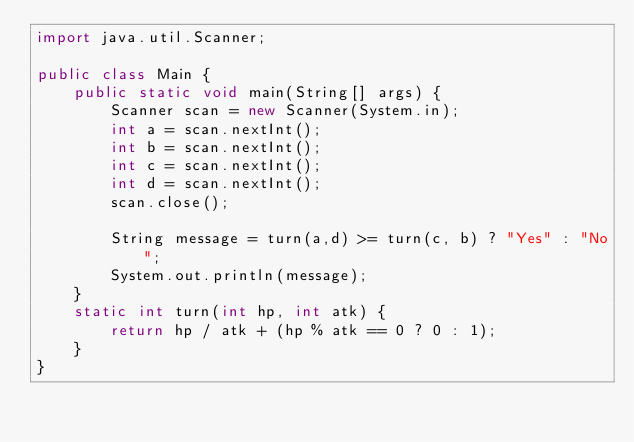Convert code to text. <code><loc_0><loc_0><loc_500><loc_500><_Java_>import java.util.Scanner;

public class Main {
    public static void main(String[] args) {
        Scanner scan = new Scanner(System.in);
        int a = scan.nextInt();
        int b = scan.nextInt();
        int c = scan.nextInt();
        int d = scan.nextInt();
        scan.close();

        String message = turn(a,d) >= turn(c, b) ? "Yes" : "No";
        System.out.println(message);
    }
    static int turn(int hp, int atk) {
        return hp / atk + (hp % atk == 0 ? 0 : 1);
    }
}

</code> 